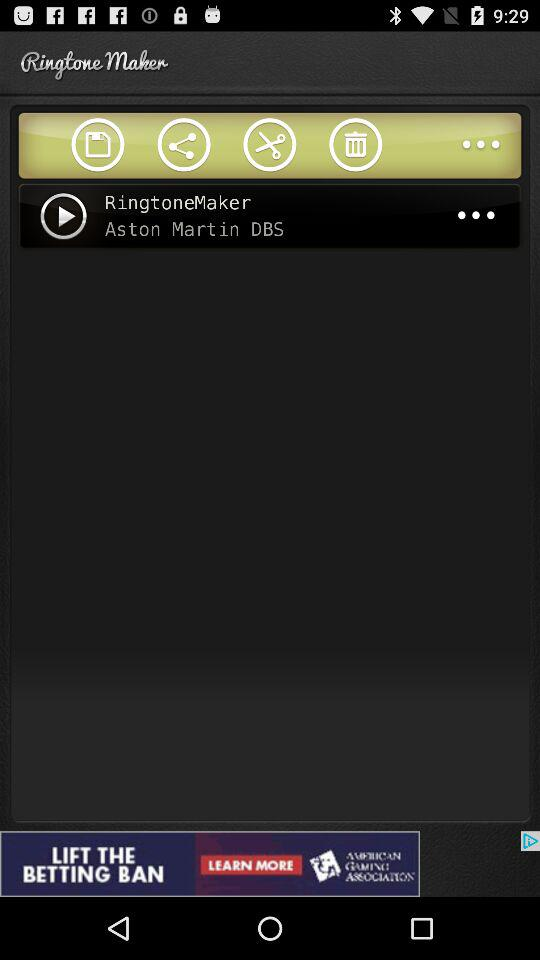What is the name of the ringtone? The name of the ringtone is "RingtoneMaker". 